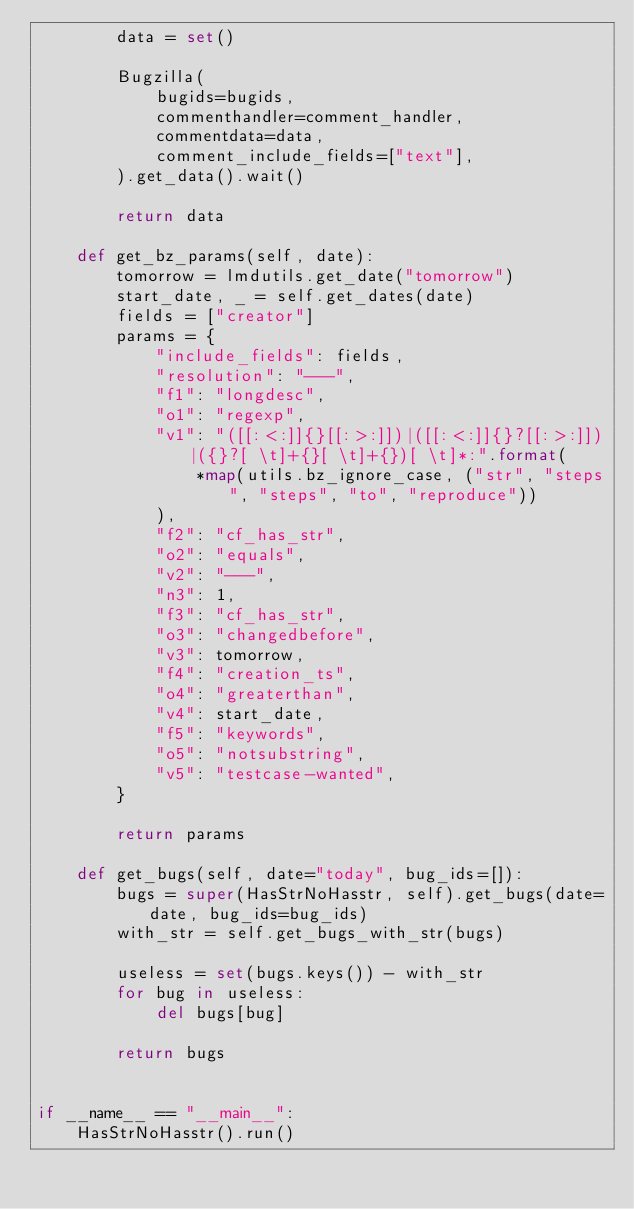Convert code to text. <code><loc_0><loc_0><loc_500><loc_500><_Python_>        data = set()

        Bugzilla(
            bugids=bugids,
            commenthandler=comment_handler,
            commentdata=data,
            comment_include_fields=["text"],
        ).get_data().wait()

        return data

    def get_bz_params(self, date):
        tomorrow = lmdutils.get_date("tomorrow")
        start_date, _ = self.get_dates(date)
        fields = ["creator"]
        params = {
            "include_fields": fields,
            "resolution": "---",
            "f1": "longdesc",
            "o1": "regexp",
            "v1": "([[:<:]]{}[[:>:]])|([[:<:]]{}?[[:>:]])|({}?[ \t]+{}[ \t]+{})[ \t]*:".format(
                *map(utils.bz_ignore_case, ("str", "steps", "steps", "to", "reproduce"))
            ),
            "f2": "cf_has_str",
            "o2": "equals",
            "v2": "---",
            "n3": 1,
            "f3": "cf_has_str",
            "o3": "changedbefore",
            "v3": tomorrow,
            "f4": "creation_ts",
            "o4": "greaterthan",
            "v4": start_date,
            "f5": "keywords",
            "o5": "notsubstring",
            "v5": "testcase-wanted",
        }

        return params

    def get_bugs(self, date="today", bug_ids=[]):
        bugs = super(HasStrNoHasstr, self).get_bugs(date=date, bug_ids=bug_ids)
        with_str = self.get_bugs_with_str(bugs)

        useless = set(bugs.keys()) - with_str
        for bug in useless:
            del bugs[bug]

        return bugs


if __name__ == "__main__":
    HasStrNoHasstr().run()
</code> 